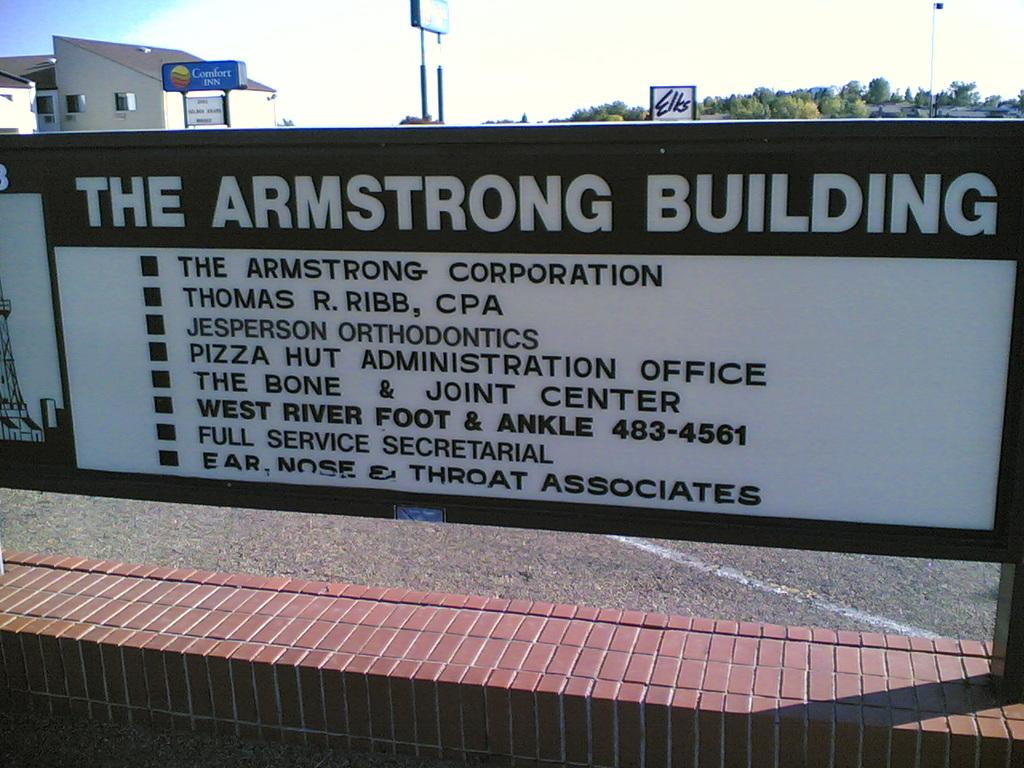What is the name of the building?
Offer a very short reply. The armstrong building. What restaurant has an administrative office in this building?
Provide a short and direct response. Pizza hut. 